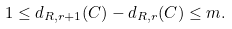<formula> <loc_0><loc_0><loc_500><loc_500>1 \leq d _ { R , r + 1 } ( C ) - d _ { R , r } ( C ) \leq m .</formula> 